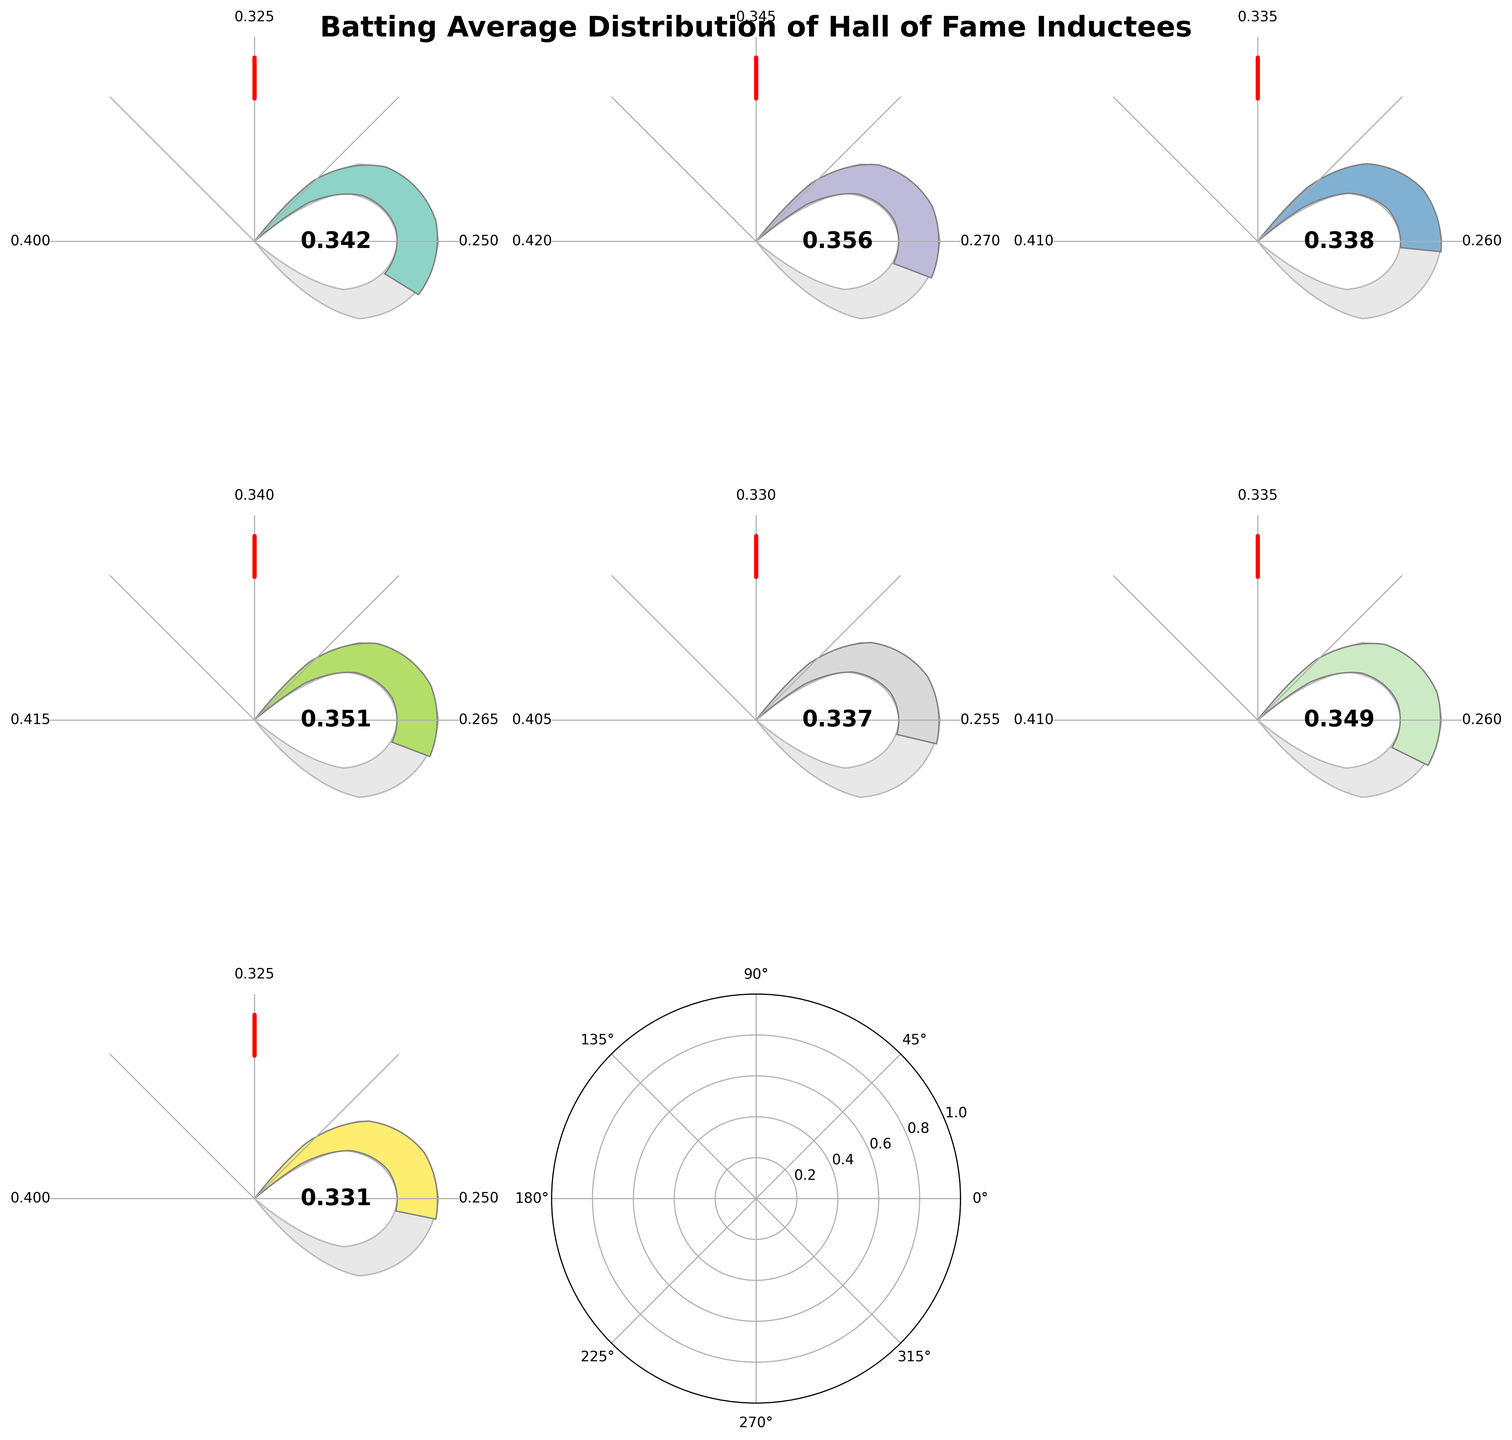What is the title of the figure? The title is typically located at the top of the figure and can be read directly. The title of this figure is "Batting Average Distribution of Hall of Fame Inductees".
Answer: Batting Average Distribution of Hall of Fame Inductees Which era has the highest current value? Look at each era's current value displayed within the gauge chart. Identify the era with the highest value. The Live Ball Era (1920-1941) shows the highest current value of 0.356.
Answer: Live Ball Era (1920-1941) What is the minimum batting average in the Dead Ball Era? Check the gauge chart for the Dead Ball Era (1900-1919) and look at the minimum value tick mark on the chart, which is 0.250.
Answer: 0.250 Which two eras have the same average batting average? Compare the average batting averages across all eras shown on the gauge chart. Both the Dead Ball Era (1900-1919) and the Post-Steroid Era (2006-Present) have the same average batting average of 0.325.
Answer: Dead Ball Era (1900-1919) and Post-Steroid Era (2006-Present) How much higher is the current value in the Expansion Era compared to the Steroid Era? Subtract the Steroid Era's current value from the Expansion Era's current value. Expansion Era's current value is 0.351 and Steroid Era's current value is 0.349. The difference is 0.351 - 0.349 = 0.002.
Answer: 0.002 What is the range of batting averages in the Free Agency Era? The range of batting averages is calculated by subtracting the minimum value from the maximum value for the Free Agency Era. The values are 0.405 (max) and 0.255 (min), so 0.405 - 0.255 = 0.150.
Answer: 0.150 What is the difference between the maximum and average batting averages in the Steroid Era? Subtract the average batting average from the maximum batting average for the Steroid Era. The values are 0.410 (max) and 0.335 (average), so 0.410 - 0.335 = 0.075.
Answer: 0.075 What is the maximum batting average shown in the entire figure? Identify the highest maximum batting average from all the eras in the figure. The highest maximum batting average is 0.420 from the Live Ball Era (1920-1941).
Answer: 0.420 